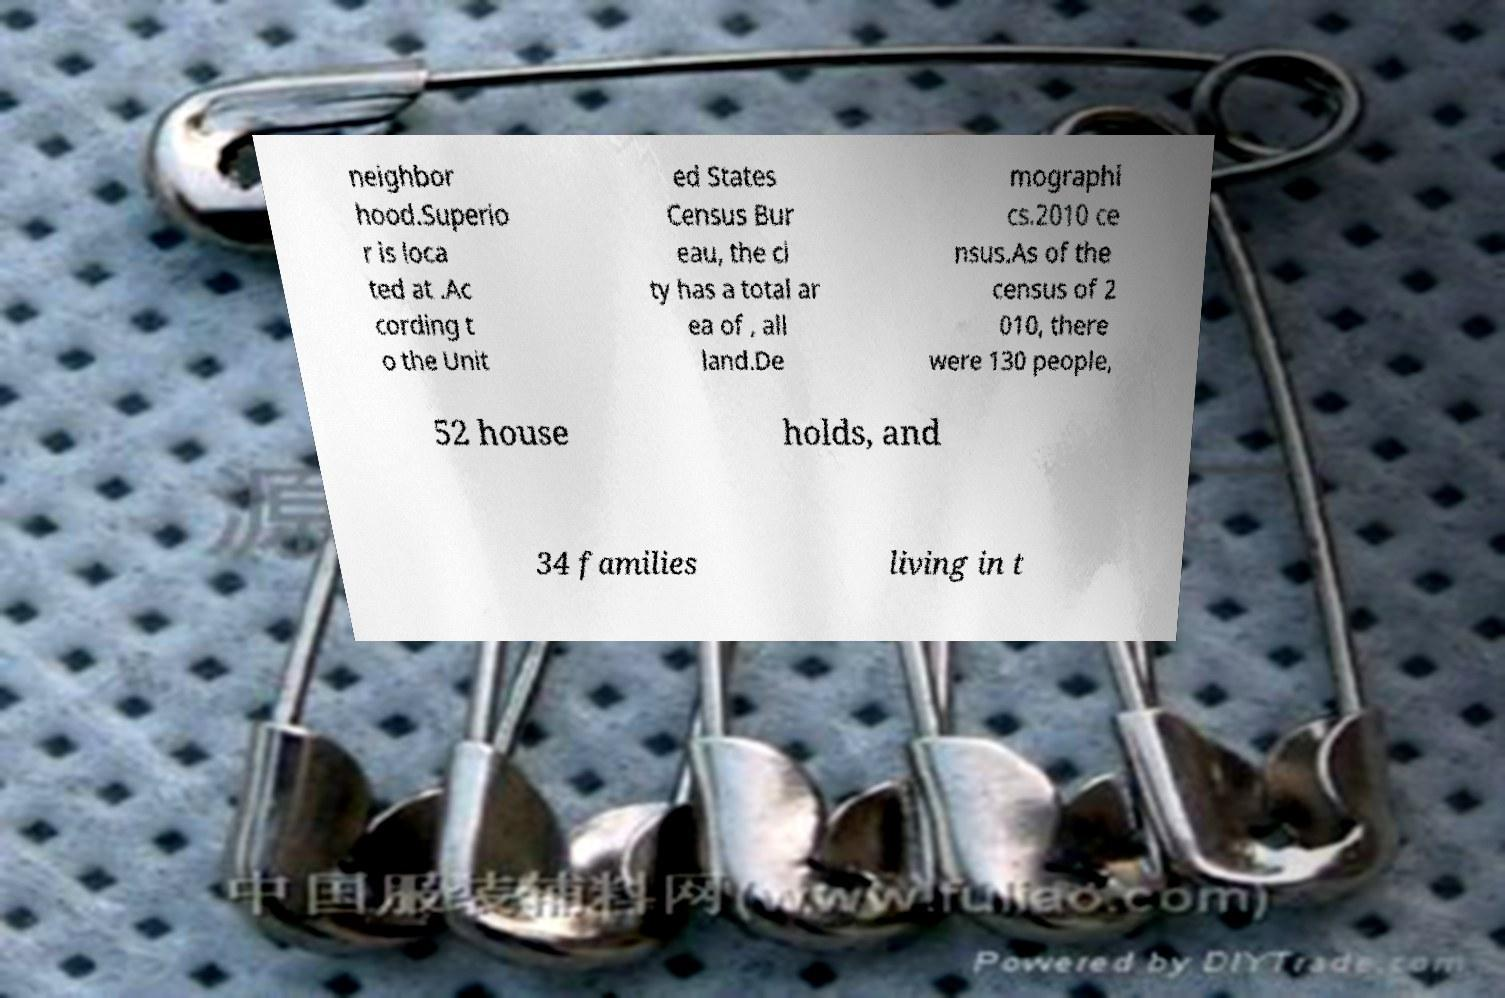Please read and relay the text visible in this image. What does it say? neighbor hood.Superio r is loca ted at .Ac cording t o the Unit ed States Census Bur eau, the ci ty has a total ar ea of , all land.De mographi cs.2010 ce nsus.As of the census of 2 010, there were 130 people, 52 house holds, and 34 families living in t 